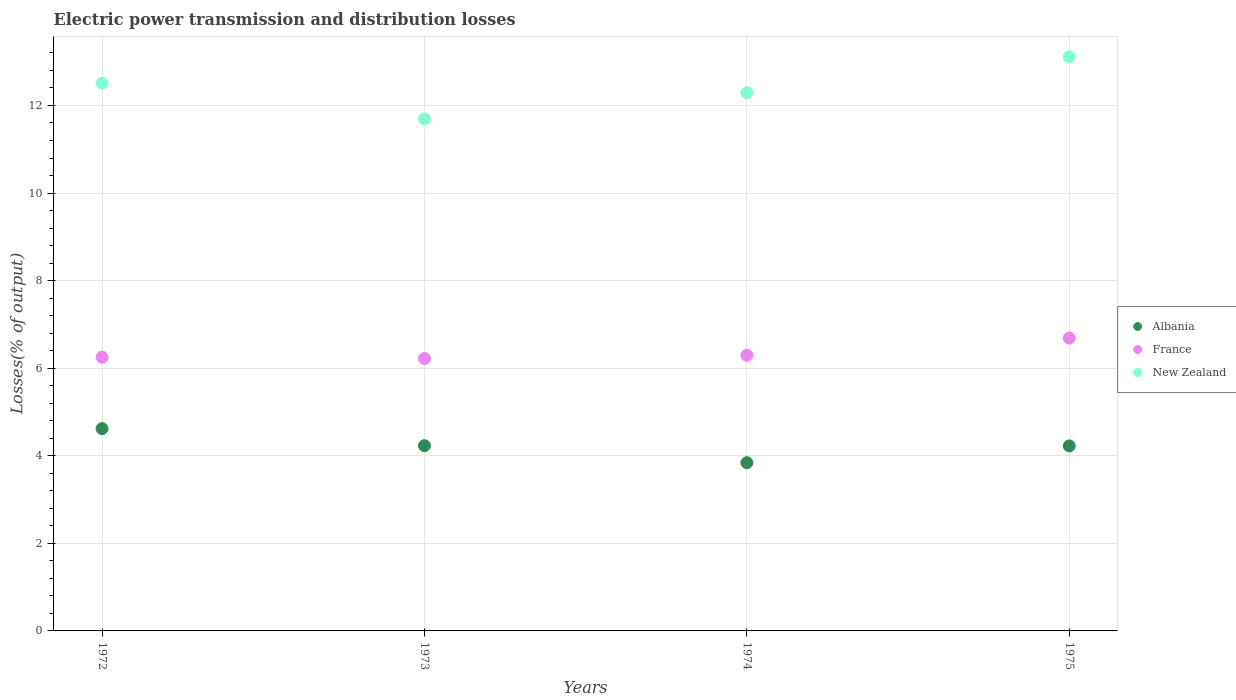What is the electric power transmission and distribution losses in Albania in 1973?
Provide a succinct answer. 4.23. Across all years, what is the maximum electric power transmission and distribution losses in New Zealand?
Ensure brevity in your answer.  13.11. Across all years, what is the minimum electric power transmission and distribution losses in France?
Ensure brevity in your answer.  6.22. In which year was the electric power transmission and distribution losses in France minimum?
Offer a terse response. 1973. What is the total electric power transmission and distribution losses in France in the graph?
Keep it short and to the point. 25.46. What is the difference between the electric power transmission and distribution losses in New Zealand in 1973 and that in 1974?
Keep it short and to the point. -0.6. What is the difference between the electric power transmission and distribution losses in New Zealand in 1975 and the electric power transmission and distribution losses in France in 1974?
Give a very brief answer. 6.82. What is the average electric power transmission and distribution losses in New Zealand per year?
Keep it short and to the point. 12.4. In the year 1975, what is the difference between the electric power transmission and distribution losses in New Zealand and electric power transmission and distribution losses in France?
Offer a terse response. 6.42. In how many years, is the electric power transmission and distribution losses in New Zealand greater than 2.4 %?
Give a very brief answer. 4. What is the ratio of the electric power transmission and distribution losses in France in 1973 to that in 1974?
Your response must be concise. 0.99. Is the difference between the electric power transmission and distribution losses in New Zealand in 1972 and 1973 greater than the difference between the electric power transmission and distribution losses in France in 1972 and 1973?
Make the answer very short. Yes. What is the difference between the highest and the second highest electric power transmission and distribution losses in New Zealand?
Provide a succinct answer. 0.6. What is the difference between the highest and the lowest electric power transmission and distribution losses in Albania?
Offer a very short reply. 0.78. In how many years, is the electric power transmission and distribution losses in France greater than the average electric power transmission and distribution losses in France taken over all years?
Your response must be concise. 1. Is the sum of the electric power transmission and distribution losses in New Zealand in 1974 and 1975 greater than the maximum electric power transmission and distribution losses in Albania across all years?
Provide a short and direct response. Yes. Does the electric power transmission and distribution losses in France monotonically increase over the years?
Provide a succinct answer. No. How many dotlines are there?
Your answer should be compact. 3. How many years are there in the graph?
Your answer should be compact. 4. Does the graph contain any zero values?
Offer a very short reply. No. How many legend labels are there?
Provide a succinct answer. 3. How are the legend labels stacked?
Your answer should be very brief. Vertical. What is the title of the graph?
Make the answer very short. Electric power transmission and distribution losses. Does "Equatorial Guinea" appear as one of the legend labels in the graph?
Keep it short and to the point. No. What is the label or title of the Y-axis?
Provide a short and direct response. Losses(% of output). What is the Losses(% of output) in Albania in 1972?
Your answer should be very brief. 4.62. What is the Losses(% of output) of France in 1972?
Keep it short and to the point. 6.25. What is the Losses(% of output) of New Zealand in 1972?
Offer a terse response. 12.51. What is the Losses(% of output) of Albania in 1973?
Ensure brevity in your answer.  4.23. What is the Losses(% of output) in France in 1973?
Provide a succinct answer. 6.22. What is the Losses(% of output) in New Zealand in 1973?
Your answer should be compact. 11.69. What is the Losses(% of output) of Albania in 1974?
Your answer should be compact. 3.84. What is the Losses(% of output) of France in 1974?
Your answer should be compact. 6.29. What is the Losses(% of output) of New Zealand in 1974?
Offer a terse response. 12.29. What is the Losses(% of output) in Albania in 1975?
Ensure brevity in your answer.  4.22. What is the Losses(% of output) of France in 1975?
Your response must be concise. 6.69. What is the Losses(% of output) of New Zealand in 1975?
Ensure brevity in your answer.  13.11. Across all years, what is the maximum Losses(% of output) in Albania?
Offer a terse response. 4.62. Across all years, what is the maximum Losses(% of output) in France?
Your response must be concise. 6.69. Across all years, what is the maximum Losses(% of output) in New Zealand?
Provide a short and direct response. 13.11. Across all years, what is the minimum Losses(% of output) in Albania?
Offer a very short reply. 3.84. Across all years, what is the minimum Losses(% of output) of France?
Make the answer very short. 6.22. Across all years, what is the minimum Losses(% of output) in New Zealand?
Provide a short and direct response. 11.69. What is the total Losses(% of output) of Albania in the graph?
Provide a succinct answer. 16.92. What is the total Losses(% of output) of France in the graph?
Provide a short and direct response. 25.46. What is the total Losses(% of output) in New Zealand in the graph?
Ensure brevity in your answer.  49.6. What is the difference between the Losses(% of output) of Albania in 1972 and that in 1973?
Give a very brief answer. 0.39. What is the difference between the Losses(% of output) in France in 1972 and that in 1973?
Your response must be concise. 0.03. What is the difference between the Losses(% of output) of New Zealand in 1972 and that in 1973?
Ensure brevity in your answer.  0.81. What is the difference between the Losses(% of output) in Albania in 1972 and that in 1974?
Keep it short and to the point. 0.78. What is the difference between the Losses(% of output) of France in 1972 and that in 1974?
Your response must be concise. -0.04. What is the difference between the Losses(% of output) of New Zealand in 1972 and that in 1974?
Your answer should be very brief. 0.22. What is the difference between the Losses(% of output) of Albania in 1972 and that in 1975?
Your answer should be compact. 0.4. What is the difference between the Losses(% of output) in France in 1972 and that in 1975?
Your response must be concise. -0.44. What is the difference between the Losses(% of output) in New Zealand in 1972 and that in 1975?
Make the answer very short. -0.6. What is the difference between the Losses(% of output) in Albania in 1973 and that in 1974?
Offer a terse response. 0.39. What is the difference between the Losses(% of output) of France in 1973 and that in 1974?
Offer a terse response. -0.07. What is the difference between the Losses(% of output) of New Zealand in 1973 and that in 1974?
Provide a short and direct response. -0.6. What is the difference between the Losses(% of output) in Albania in 1973 and that in 1975?
Your answer should be compact. 0.01. What is the difference between the Losses(% of output) of France in 1973 and that in 1975?
Your answer should be compact. -0.47. What is the difference between the Losses(% of output) of New Zealand in 1973 and that in 1975?
Ensure brevity in your answer.  -1.42. What is the difference between the Losses(% of output) of Albania in 1974 and that in 1975?
Make the answer very short. -0.38. What is the difference between the Losses(% of output) of France in 1974 and that in 1975?
Make the answer very short. -0.39. What is the difference between the Losses(% of output) of New Zealand in 1974 and that in 1975?
Keep it short and to the point. -0.82. What is the difference between the Losses(% of output) of Albania in 1972 and the Losses(% of output) of France in 1973?
Provide a short and direct response. -1.6. What is the difference between the Losses(% of output) in Albania in 1972 and the Losses(% of output) in New Zealand in 1973?
Your answer should be very brief. -7.07. What is the difference between the Losses(% of output) of France in 1972 and the Losses(% of output) of New Zealand in 1973?
Your answer should be very brief. -5.44. What is the difference between the Losses(% of output) in Albania in 1972 and the Losses(% of output) in France in 1974?
Your response must be concise. -1.67. What is the difference between the Losses(% of output) of Albania in 1972 and the Losses(% of output) of New Zealand in 1974?
Your answer should be very brief. -7.67. What is the difference between the Losses(% of output) of France in 1972 and the Losses(% of output) of New Zealand in 1974?
Give a very brief answer. -6.04. What is the difference between the Losses(% of output) in Albania in 1972 and the Losses(% of output) in France in 1975?
Provide a succinct answer. -2.07. What is the difference between the Losses(% of output) of Albania in 1972 and the Losses(% of output) of New Zealand in 1975?
Give a very brief answer. -8.49. What is the difference between the Losses(% of output) in France in 1972 and the Losses(% of output) in New Zealand in 1975?
Your answer should be very brief. -6.86. What is the difference between the Losses(% of output) of Albania in 1973 and the Losses(% of output) of France in 1974?
Your answer should be very brief. -2.06. What is the difference between the Losses(% of output) of Albania in 1973 and the Losses(% of output) of New Zealand in 1974?
Provide a succinct answer. -8.06. What is the difference between the Losses(% of output) of France in 1973 and the Losses(% of output) of New Zealand in 1974?
Provide a succinct answer. -6.07. What is the difference between the Losses(% of output) in Albania in 1973 and the Losses(% of output) in France in 1975?
Make the answer very short. -2.46. What is the difference between the Losses(% of output) in Albania in 1973 and the Losses(% of output) in New Zealand in 1975?
Give a very brief answer. -8.88. What is the difference between the Losses(% of output) of France in 1973 and the Losses(% of output) of New Zealand in 1975?
Offer a terse response. -6.89. What is the difference between the Losses(% of output) of Albania in 1974 and the Losses(% of output) of France in 1975?
Your response must be concise. -2.85. What is the difference between the Losses(% of output) of Albania in 1974 and the Losses(% of output) of New Zealand in 1975?
Offer a very short reply. -9.27. What is the difference between the Losses(% of output) in France in 1974 and the Losses(% of output) in New Zealand in 1975?
Offer a terse response. -6.82. What is the average Losses(% of output) in Albania per year?
Your answer should be compact. 4.23. What is the average Losses(% of output) of France per year?
Offer a terse response. 6.36. What is the average Losses(% of output) in New Zealand per year?
Your response must be concise. 12.4. In the year 1972, what is the difference between the Losses(% of output) in Albania and Losses(% of output) in France?
Provide a succinct answer. -1.63. In the year 1972, what is the difference between the Losses(% of output) of Albania and Losses(% of output) of New Zealand?
Ensure brevity in your answer.  -7.89. In the year 1972, what is the difference between the Losses(% of output) of France and Losses(% of output) of New Zealand?
Your answer should be very brief. -6.26. In the year 1973, what is the difference between the Losses(% of output) of Albania and Losses(% of output) of France?
Give a very brief answer. -1.99. In the year 1973, what is the difference between the Losses(% of output) in Albania and Losses(% of output) in New Zealand?
Offer a terse response. -7.46. In the year 1973, what is the difference between the Losses(% of output) in France and Losses(% of output) in New Zealand?
Keep it short and to the point. -5.47. In the year 1974, what is the difference between the Losses(% of output) of Albania and Losses(% of output) of France?
Give a very brief answer. -2.45. In the year 1974, what is the difference between the Losses(% of output) in Albania and Losses(% of output) in New Zealand?
Keep it short and to the point. -8.45. In the year 1974, what is the difference between the Losses(% of output) of France and Losses(% of output) of New Zealand?
Your answer should be compact. -6. In the year 1975, what is the difference between the Losses(% of output) of Albania and Losses(% of output) of France?
Your answer should be very brief. -2.46. In the year 1975, what is the difference between the Losses(% of output) in Albania and Losses(% of output) in New Zealand?
Your answer should be compact. -8.89. In the year 1975, what is the difference between the Losses(% of output) of France and Losses(% of output) of New Zealand?
Your answer should be very brief. -6.42. What is the ratio of the Losses(% of output) in Albania in 1972 to that in 1973?
Make the answer very short. 1.09. What is the ratio of the Losses(% of output) in New Zealand in 1972 to that in 1973?
Provide a short and direct response. 1.07. What is the ratio of the Losses(% of output) of Albania in 1972 to that in 1974?
Keep it short and to the point. 1.2. What is the ratio of the Losses(% of output) in France in 1972 to that in 1974?
Your response must be concise. 0.99. What is the ratio of the Losses(% of output) of New Zealand in 1972 to that in 1974?
Your answer should be compact. 1.02. What is the ratio of the Losses(% of output) in Albania in 1972 to that in 1975?
Your answer should be very brief. 1.09. What is the ratio of the Losses(% of output) in France in 1972 to that in 1975?
Provide a succinct answer. 0.93. What is the ratio of the Losses(% of output) in New Zealand in 1972 to that in 1975?
Offer a terse response. 0.95. What is the ratio of the Losses(% of output) in Albania in 1973 to that in 1974?
Provide a succinct answer. 1.1. What is the ratio of the Losses(% of output) in France in 1973 to that in 1974?
Offer a terse response. 0.99. What is the ratio of the Losses(% of output) in New Zealand in 1973 to that in 1974?
Offer a very short reply. 0.95. What is the ratio of the Losses(% of output) in Albania in 1973 to that in 1975?
Your response must be concise. 1. What is the ratio of the Losses(% of output) in France in 1973 to that in 1975?
Ensure brevity in your answer.  0.93. What is the ratio of the Losses(% of output) of New Zealand in 1973 to that in 1975?
Provide a short and direct response. 0.89. What is the ratio of the Losses(% of output) of Albania in 1974 to that in 1975?
Your response must be concise. 0.91. What is the ratio of the Losses(% of output) of New Zealand in 1974 to that in 1975?
Provide a succinct answer. 0.94. What is the difference between the highest and the second highest Losses(% of output) of Albania?
Give a very brief answer. 0.39. What is the difference between the highest and the second highest Losses(% of output) of France?
Keep it short and to the point. 0.39. What is the difference between the highest and the second highest Losses(% of output) of New Zealand?
Your answer should be compact. 0.6. What is the difference between the highest and the lowest Losses(% of output) of Albania?
Your answer should be compact. 0.78. What is the difference between the highest and the lowest Losses(% of output) of France?
Keep it short and to the point. 0.47. What is the difference between the highest and the lowest Losses(% of output) in New Zealand?
Your answer should be compact. 1.42. 